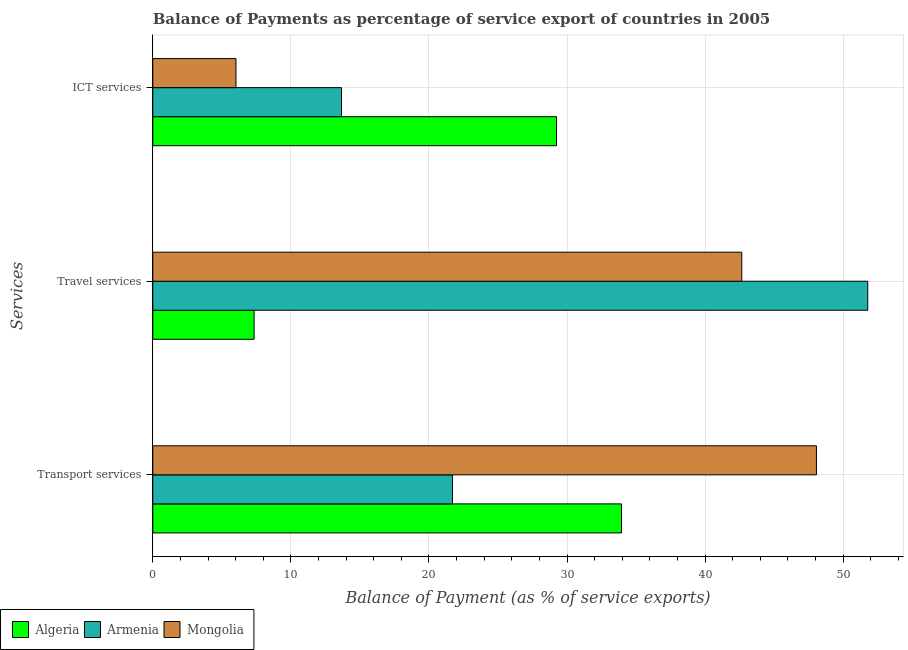Are the number of bars per tick equal to the number of legend labels?
Offer a terse response. Yes. Are the number of bars on each tick of the Y-axis equal?
Offer a terse response. Yes. What is the label of the 3rd group of bars from the top?
Keep it short and to the point. Transport services. What is the balance of payment of ict services in Mongolia?
Ensure brevity in your answer.  6.02. Across all countries, what is the maximum balance of payment of ict services?
Your answer should be very brief. 29.24. Across all countries, what is the minimum balance of payment of ict services?
Your response must be concise. 6.02. In which country was the balance of payment of travel services maximum?
Your answer should be compact. Armenia. In which country was the balance of payment of travel services minimum?
Your response must be concise. Algeria. What is the total balance of payment of ict services in the graph?
Your answer should be compact. 48.93. What is the difference between the balance of payment of transport services in Armenia and that in Algeria?
Your answer should be compact. -12.24. What is the difference between the balance of payment of ict services in Armenia and the balance of payment of transport services in Mongolia?
Ensure brevity in your answer.  -34.4. What is the average balance of payment of ict services per country?
Ensure brevity in your answer.  16.31. What is the difference between the balance of payment of ict services and balance of payment of travel services in Mongolia?
Make the answer very short. -36.63. In how many countries, is the balance of payment of transport services greater than 36 %?
Offer a terse response. 1. What is the ratio of the balance of payment of ict services in Mongolia to that in Armenia?
Provide a short and direct response. 0.44. Is the difference between the balance of payment of travel services in Armenia and Algeria greater than the difference between the balance of payment of ict services in Armenia and Algeria?
Keep it short and to the point. Yes. What is the difference between the highest and the second highest balance of payment of transport services?
Give a very brief answer. 14.12. What is the difference between the highest and the lowest balance of payment of travel services?
Provide a short and direct response. 44.44. What does the 1st bar from the top in ICT services represents?
Give a very brief answer. Mongolia. What does the 1st bar from the bottom in Travel services represents?
Offer a terse response. Algeria. Is it the case that in every country, the sum of the balance of payment of transport services and balance of payment of travel services is greater than the balance of payment of ict services?
Your response must be concise. Yes. How many bars are there?
Provide a short and direct response. 9. Are all the bars in the graph horizontal?
Your response must be concise. Yes. How many countries are there in the graph?
Ensure brevity in your answer.  3. Does the graph contain any zero values?
Make the answer very short. No. Where does the legend appear in the graph?
Provide a succinct answer. Bottom left. How are the legend labels stacked?
Ensure brevity in your answer.  Horizontal. What is the title of the graph?
Ensure brevity in your answer.  Balance of Payments as percentage of service export of countries in 2005. Does "Trinidad and Tobago" appear as one of the legend labels in the graph?
Your answer should be very brief. No. What is the label or title of the X-axis?
Keep it short and to the point. Balance of Payment (as % of service exports). What is the label or title of the Y-axis?
Provide a short and direct response. Services. What is the Balance of Payment (as % of service exports) in Algeria in Transport services?
Offer a very short reply. 33.94. What is the Balance of Payment (as % of service exports) in Armenia in Transport services?
Keep it short and to the point. 21.7. What is the Balance of Payment (as % of service exports) of Mongolia in Transport services?
Offer a very short reply. 48.06. What is the Balance of Payment (as % of service exports) in Algeria in Travel services?
Give a very brief answer. 7.34. What is the Balance of Payment (as % of service exports) in Armenia in Travel services?
Your answer should be compact. 51.78. What is the Balance of Payment (as % of service exports) of Mongolia in Travel services?
Provide a succinct answer. 42.65. What is the Balance of Payment (as % of service exports) of Algeria in ICT services?
Offer a terse response. 29.24. What is the Balance of Payment (as % of service exports) of Armenia in ICT services?
Your answer should be very brief. 13.67. What is the Balance of Payment (as % of service exports) of Mongolia in ICT services?
Ensure brevity in your answer.  6.02. Across all Services, what is the maximum Balance of Payment (as % of service exports) of Algeria?
Your answer should be very brief. 33.94. Across all Services, what is the maximum Balance of Payment (as % of service exports) in Armenia?
Your answer should be compact. 51.78. Across all Services, what is the maximum Balance of Payment (as % of service exports) of Mongolia?
Give a very brief answer. 48.06. Across all Services, what is the minimum Balance of Payment (as % of service exports) of Algeria?
Offer a very short reply. 7.34. Across all Services, what is the minimum Balance of Payment (as % of service exports) in Armenia?
Keep it short and to the point. 13.67. Across all Services, what is the minimum Balance of Payment (as % of service exports) in Mongolia?
Give a very brief answer. 6.02. What is the total Balance of Payment (as % of service exports) of Algeria in the graph?
Your answer should be compact. 70.52. What is the total Balance of Payment (as % of service exports) in Armenia in the graph?
Offer a terse response. 87.15. What is the total Balance of Payment (as % of service exports) in Mongolia in the graph?
Your response must be concise. 96.74. What is the difference between the Balance of Payment (as % of service exports) in Algeria in Transport services and that in Travel services?
Make the answer very short. 26.61. What is the difference between the Balance of Payment (as % of service exports) in Armenia in Transport services and that in Travel services?
Provide a succinct answer. -30.07. What is the difference between the Balance of Payment (as % of service exports) in Mongolia in Transport services and that in Travel services?
Your response must be concise. 5.41. What is the difference between the Balance of Payment (as % of service exports) in Algeria in Transport services and that in ICT services?
Provide a succinct answer. 4.71. What is the difference between the Balance of Payment (as % of service exports) of Armenia in Transport services and that in ICT services?
Ensure brevity in your answer.  8.04. What is the difference between the Balance of Payment (as % of service exports) in Mongolia in Transport services and that in ICT services?
Offer a terse response. 42.04. What is the difference between the Balance of Payment (as % of service exports) in Algeria in Travel services and that in ICT services?
Provide a succinct answer. -21.9. What is the difference between the Balance of Payment (as % of service exports) of Armenia in Travel services and that in ICT services?
Give a very brief answer. 38.11. What is the difference between the Balance of Payment (as % of service exports) in Mongolia in Travel services and that in ICT services?
Your answer should be very brief. 36.63. What is the difference between the Balance of Payment (as % of service exports) of Algeria in Transport services and the Balance of Payment (as % of service exports) of Armenia in Travel services?
Ensure brevity in your answer.  -17.83. What is the difference between the Balance of Payment (as % of service exports) in Algeria in Transport services and the Balance of Payment (as % of service exports) in Mongolia in Travel services?
Your response must be concise. -8.71. What is the difference between the Balance of Payment (as % of service exports) in Armenia in Transport services and the Balance of Payment (as % of service exports) in Mongolia in Travel services?
Keep it short and to the point. -20.95. What is the difference between the Balance of Payment (as % of service exports) in Algeria in Transport services and the Balance of Payment (as % of service exports) in Armenia in ICT services?
Give a very brief answer. 20.28. What is the difference between the Balance of Payment (as % of service exports) of Algeria in Transport services and the Balance of Payment (as % of service exports) of Mongolia in ICT services?
Offer a very short reply. 27.92. What is the difference between the Balance of Payment (as % of service exports) of Armenia in Transport services and the Balance of Payment (as % of service exports) of Mongolia in ICT services?
Make the answer very short. 15.68. What is the difference between the Balance of Payment (as % of service exports) of Algeria in Travel services and the Balance of Payment (as % of service exports) of Armenia in ICT services?
Give a very brief answer. -6.33. What is the difference between the Balance of Payment (as % of service exports) in Algeria in Travel services and the Balance of Payment (as % of service exports) in Mongolia in ICT services?
Keep it short and to the point. 1.31. What is the difference between the Balance of Payment (as % of service exports) in Armenia in Travel services and the Balance of Payment (as % of service exports) in Mongolia in ICT services?
Your answer should be compact. 45.75. What is the average Balance of Payment (as % of service exports) of Algeria per Services?
Keep it short and to the point. 23.51. What is the average Balance of Payment (as % of service exports) in Armenia per Services?
Keep it short and to the point. 29.05. What is the average Balance of Payment (as % of service exports) in Mongolia per Services?
Make the answer very short. 32.25. What is the difference between the Balance of Payment (as % of service exports) in Algeria and Balance of Payment (as % of service exports) in Armenia in Transport services?
Make the answer very short. 12.24. What is the difference between the Balance of Payment (as % of service exports) of Algeria and Balance of Payment (as % of service exports) of Mongolia in Transport services?
Offer a very short reply. -14.12. What is the difference between the Balance of Payment (as % of service exports) of Armenia and Balance of Payment (as % of service exports) of Mongolia in Transport services?
Give a very brief answer. -26.36. What is the difference between the Balance of Payment (as % of service exports) of Algeria and Balance of Payment (as % of service exports) of Armenia in Travel services?
Your answer should be very brief. -44.44. What is the difference between the Balance of Payment (as % of service exports) of Algeria and Balance of Payment (as % of service exports) of Mongolia in Travel services?
Your response must be concise. -35.31. What is the difference between the Balance of Payment (as % of service exports) of Armenia and Balance of Payment (as % of service exports) of Mongolia in Travel services?
Provide a succinct answer. 9.12. What is the difference between the Balance of Payment (as % of service exports) in Algeria and Balance of Payment (as % of service exports) in Armenia in ICT services?
Keep it short and to the point. 15.57. What is the difference between the Balance of Payment (as % of service exports) of Algeria and Balance of Payment (as % of service exports) of Mongolia in ICT services?
Give a very brief answer. 23.21. What is the difference between the Balance of Payment (as % of service exports) of Armenia and Balance of Payment (as % of service exports) of Mongolia in ICT services?
Ensure brevity in your answer.  7.64. What is the ratio of the Balance of Payment (as % of service exports) in Algeria in Transport services to that in Travel services?
Make the answer very short. 4.62. What is the ratio of the Balance of Payment (as % of service exports) in Armenia in Transport services to that in Travel services?
Give a very brief answer. 0.42. What is the ratio of the Balance of Payment (as % of service exports) in Mongolia in Transport services to that in Travel services?
Make the answer very short. 1.13. What is the ratio of the Balance of Payment (as % of service exports) in Algeria in Transport services to that in ICT services?
Make the answer very short. 1.16. What is the ratio of the Balance of Payment (as % of service exports) of Armenia in Transport services to that in ICT services?
Give a very brief answer. 1.59. What is the ratio of the Balance of Payment (as % of service exports) of Mongolia in Transport services to that in ICT services?
Keep it short and to the point. 7.98. What is the ratio of the Balance of Payment (as % of service exports) in Algeria in Travel services to that in ICT services?
Keep it short and to the point. 0.25. What is the ratio of the Balance of Payment (as % of service exports) in Armenia in Travel services to that in ICT services?
Your answer should be compact. 3.79. What is the ratio of the Balance of Payment (as % of service exports) in Mongolia in Travel services to that in ICT services?
Give a very brief answer. 7.08. What is the difference between the highest and the second highest Balance of Payment (as % of service exports) of Algeria?
Ensure brevity in your answer.  4.71. What is the difference between the highest and the second highest Balance of Payment (as % of service exports) in Armenia?
Offer a terse response. 30.07. What is the difference between the highest and the second highest Balance of Payment (as % of service exports) of Mongolia?
Your answer should be compact. 5.41. What is the difference between the highest and the lowest Balance of Payment (as % of service exports) of Algeria?
Provide a succinct answer. 26.61. What is the difference between the highest and the lowest Balance of Payment (as % of service exports) in Armenia?
Ensure brevity in your answer.  38.11. What is the difference between the highest and the lowest Balance of Payment (as % of service exports) in Mongolia?
Your answer should be very brief. 42.04. 